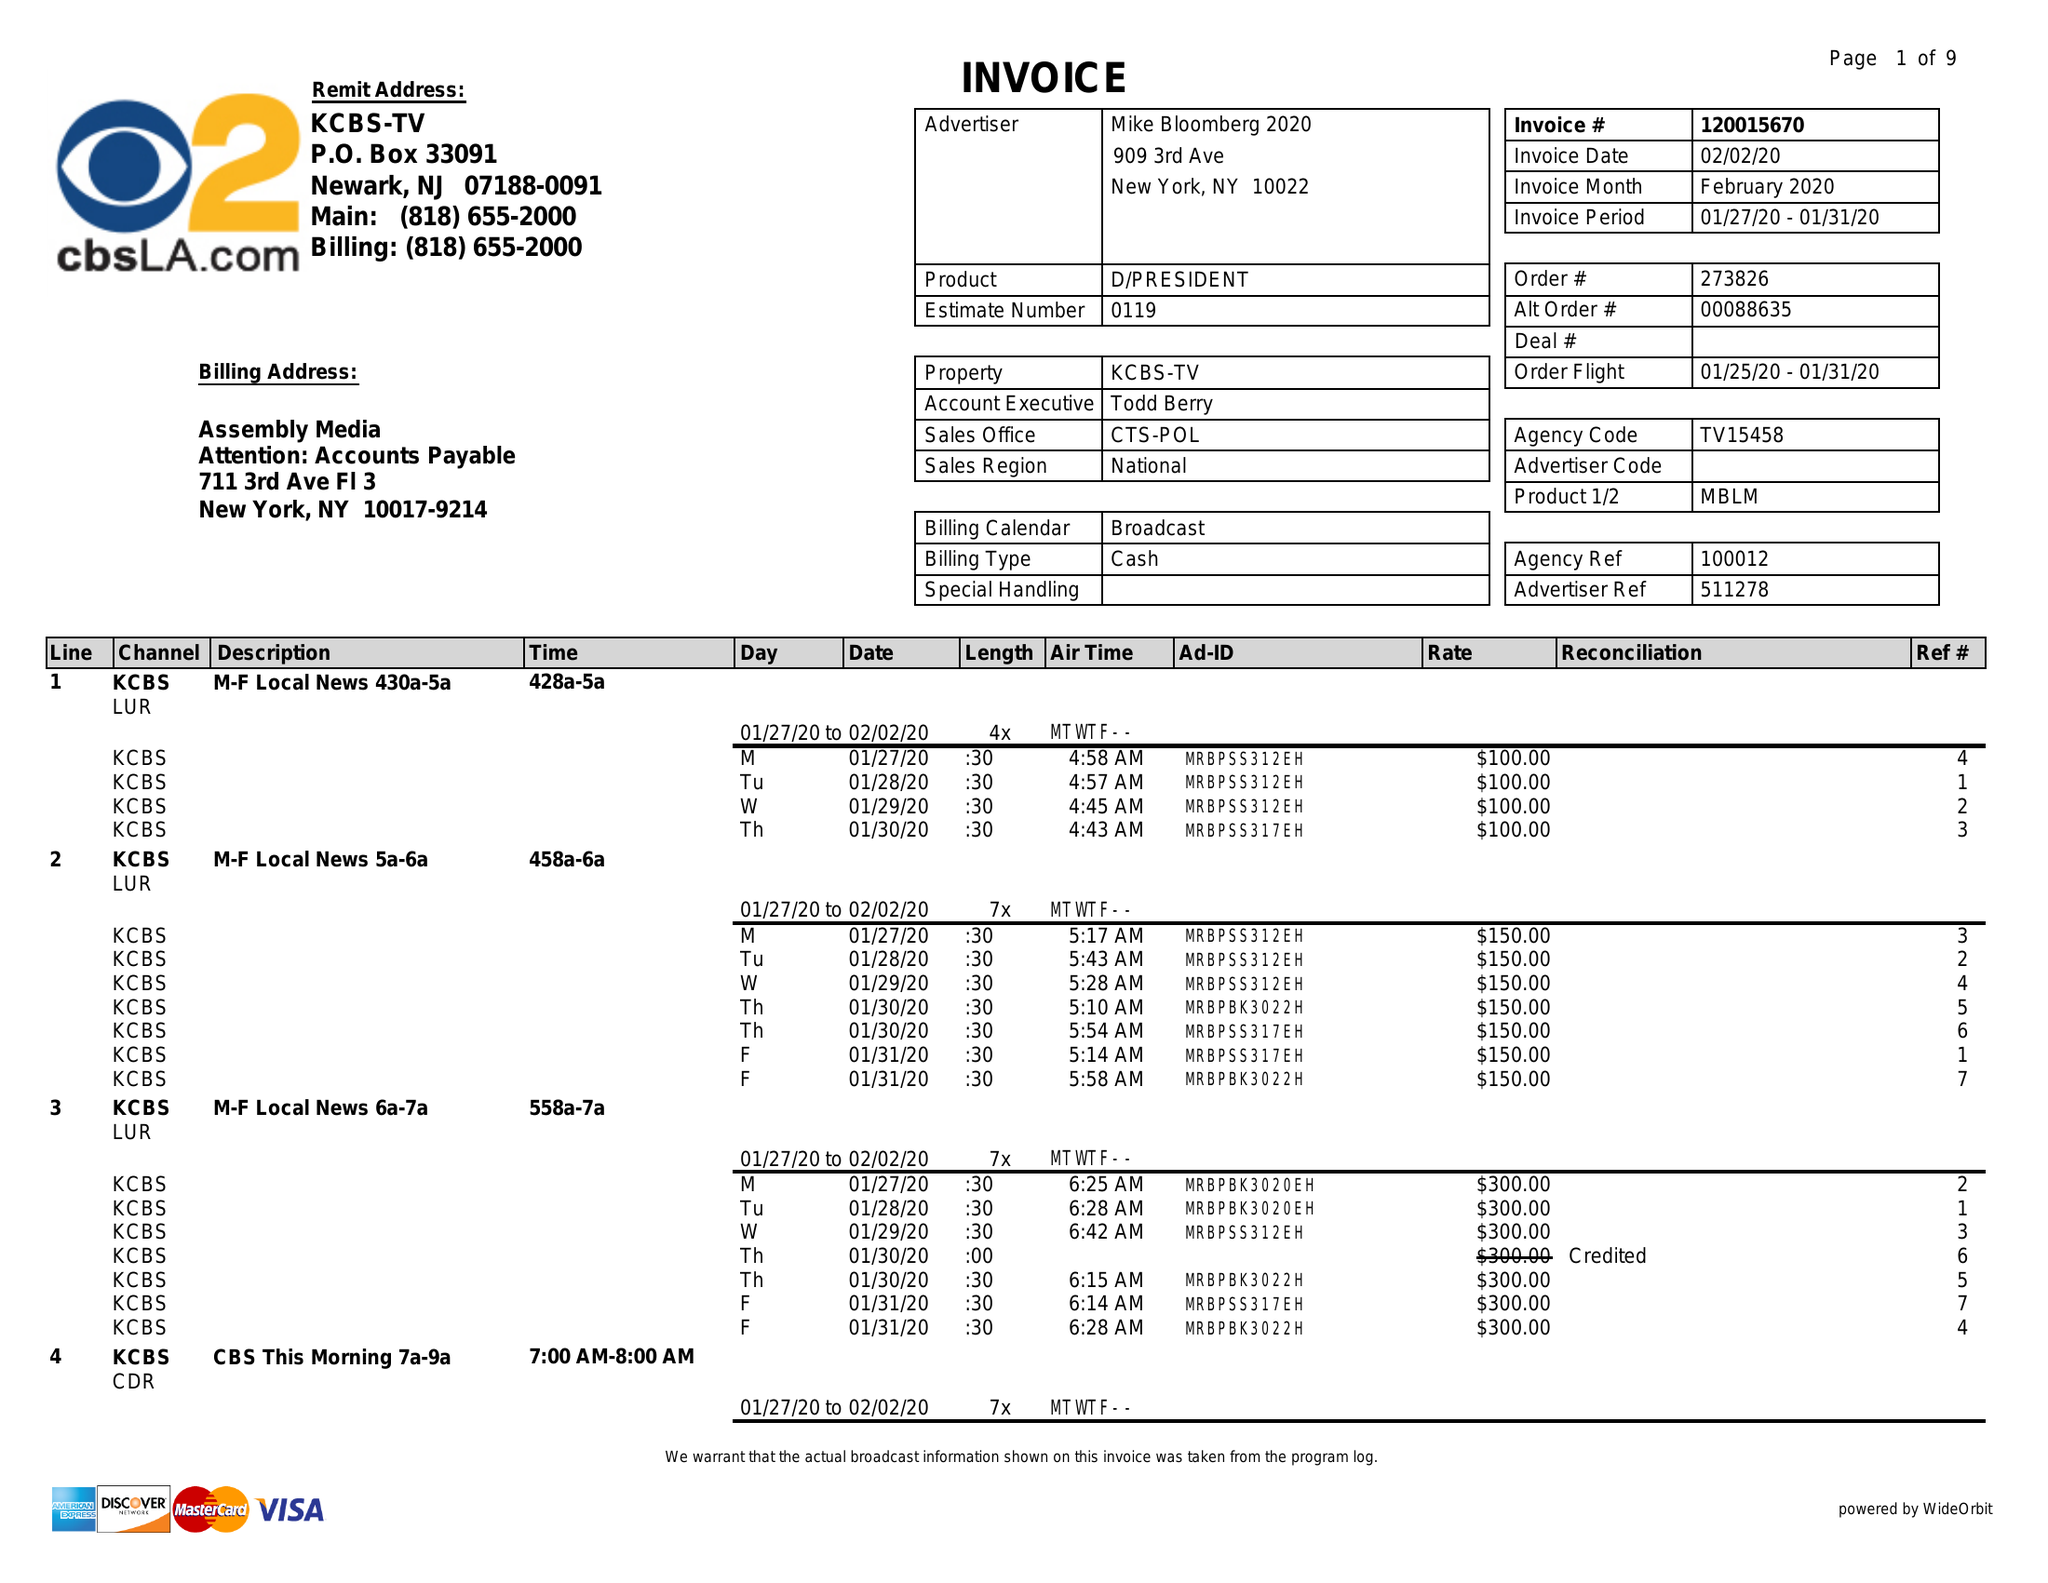What is the value for the contract_num?
Answer the question using a single word or phrase. 120015670 